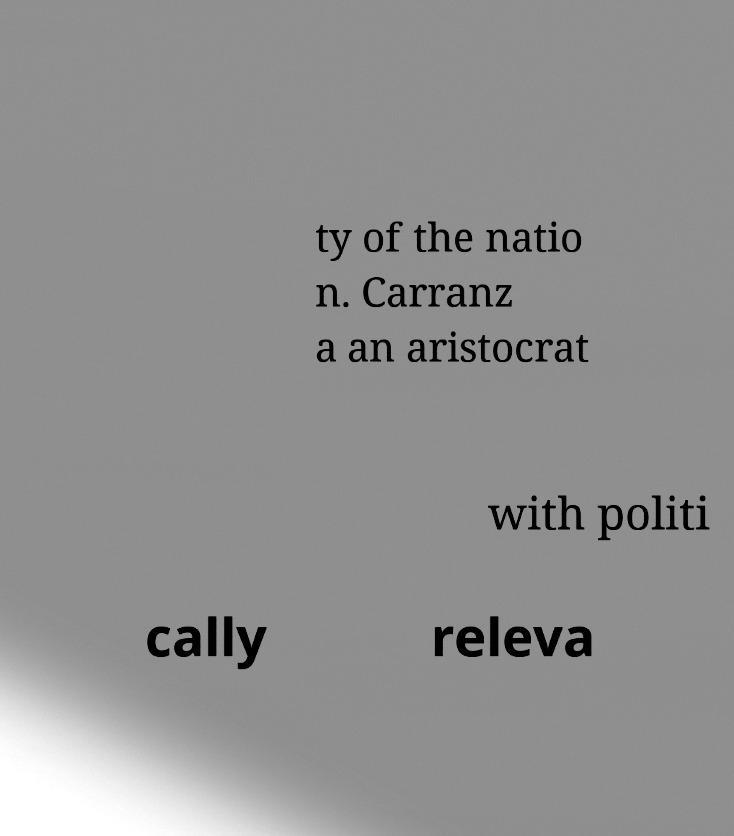Please identify and transcribe the text found in this image. ty of the natio n. Carranz a an aristocrat with politi cally releva 